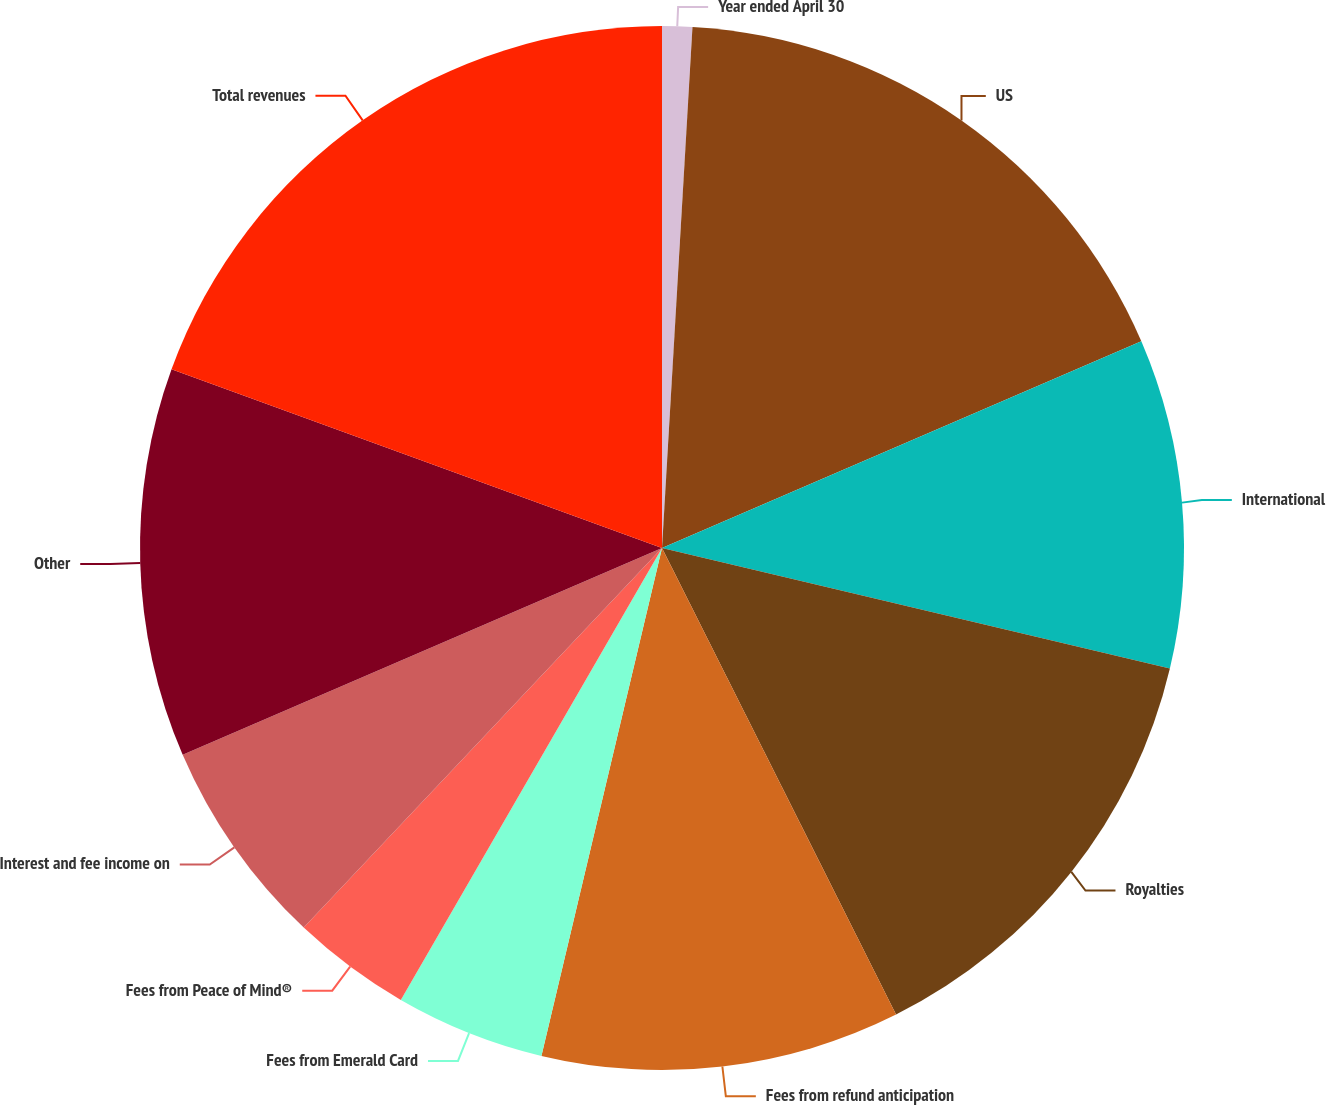Convert chart. <chart><loc_0><loc_0><loc_500><loc_500><pie_chart><fcel>Year ended April 30<fcel>US<fcel>International<fcel>Royalties<fcel>Fees from refund anticipation<fcel>Fees from Emerald Card<fcel>Fees from Peace of Mind®<fcel>Interest and fee income on<fcel>Other<fcel>Total revenues<nl><fcel>0.93%<fcel>17.59%<fcel>10.19%<fcel>13.89%<fcel>11.11%<fcel>4.63%<fcel>3.7%<fcel>6.48%<fcel>12.04%<fcel>19.44%<nl></chart> 